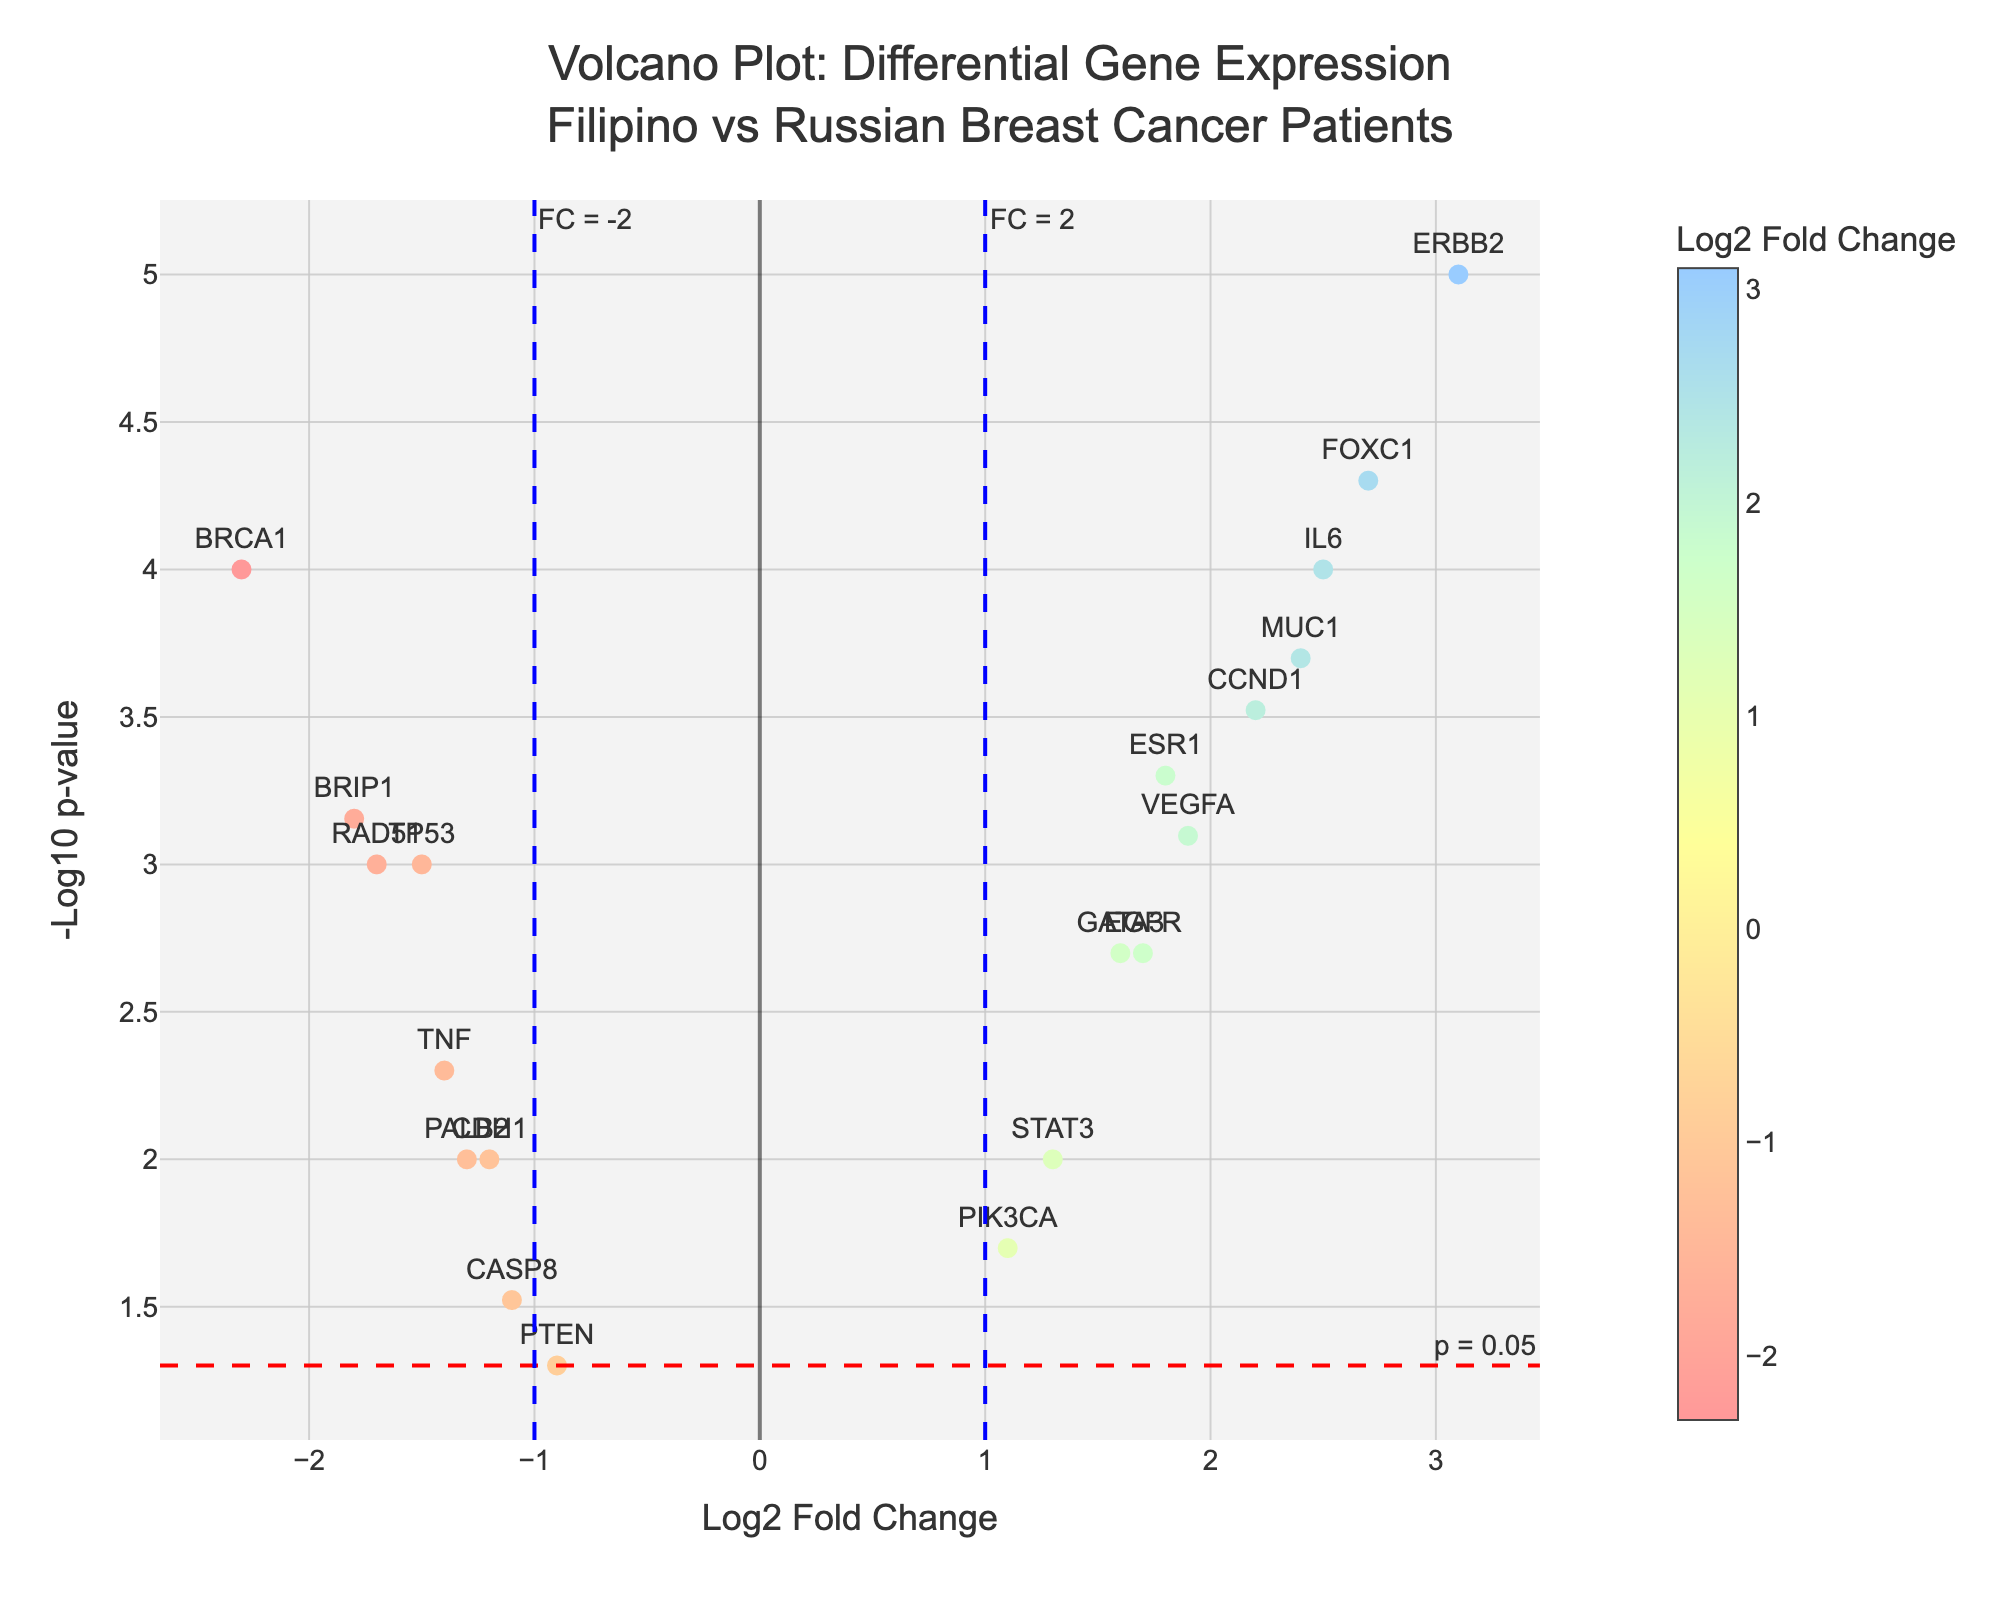What is the title of the figure? The title of the figure is positioned at the top and describes the context of the plot. It reads "Volcano Plot: Differential Gene Expression Filipino vs Russian Breast Cancer Patients."
Answer: Volcano Plot: Differential Gene Expression Filipino vs Russian Breast Cancer Patients What do the x-axis and y-axis represent? The x-axis represents the Log2 Fold Change, indicating the ratio of gene expression between the Filipino and Russian patient populations. The y-axis represents the -Log10 p-value, indicating the statistical significance of the gene expression changes.
Answer: x-axis: Log2 Fold Change, y-axis: -Log10 p-value Which gene has the highest Log2 Fold Change, and what is its value? The highest Log2 Fold Change is given to the gene ERBB2, which is clearly marked at the top far right of the plot. From the hover information, it can be seen that the Log2 Fold Change value is 3.1.
Answer: ERBB2, 3.1 Which genes have p-values less than 0.001? To identify genes with p-values less than 0.001, look for points above the horizontal red dashed line (which marks -Log10(0.05)). The matching genes are BRCA1, ERBB2, MUC1, FOXC1, CCND1, IL6, and BRIP1.
Answer: BRCA1, ERBB2, MUC1, FOXC1, CCND1, IL6, BRIP1 What does the red dashed horizontal line represent? The red dashed horizontal line represents the threshold where the p-value equals 0.05. Any points above this line indicate genes with p-values less than 0.05, suggesting statistical significance.
Answer: p = 0.05 How many genes have a Log2 Fold Change greater than 2? To count the genes with a Log2 Fold Change greater than 2, locate the points rightwards of the vertical dashed blue line at Log2 FC = 2. The genes are ERBB2, MUC1, FOXC1, CCND1, and IL6, which totals to 5 genes.
Answer: 5 Which gene has the most statistically significant p-value, and what is its value? The most statistically significant p-value corresponds to the gene that is furthest up on the y-axis. This gene is ERBB2 with a p-value of 0.00001, as indicated in the hover text.
Answer: ERBB2, 0.00001 Which gene has a Log2 Fold Change closest to zero but is still statistically significant (p < 0.05)? The gene closest to the vertical center (Log2 Fold Change = 0) but above the red dashed line (statistically significant) is PIK3CA with a Log2 Fold Change of 1.1 and a p-value of 0.02.
Answer: PIK3CA Which gene is downregulated the most, and by how much? Downregulated genes have negative Log2 Fold Change values. The gene with the lowest Log2 Fold Change, thus downregulated the most, is BRCA1 with a Log2 Fold Change of -2.3.
Answer: BRCA1, -2.3 